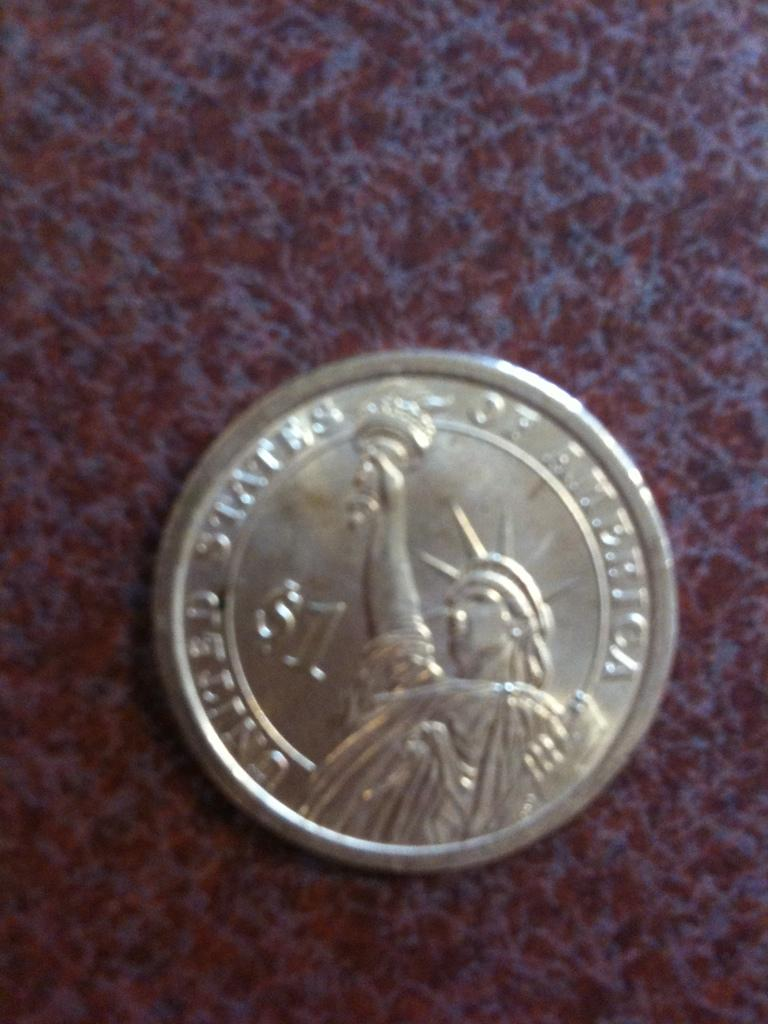<image>
Render a clear and concise summary of the photo. A coin that says United States of America with the statue of liberty on it. 